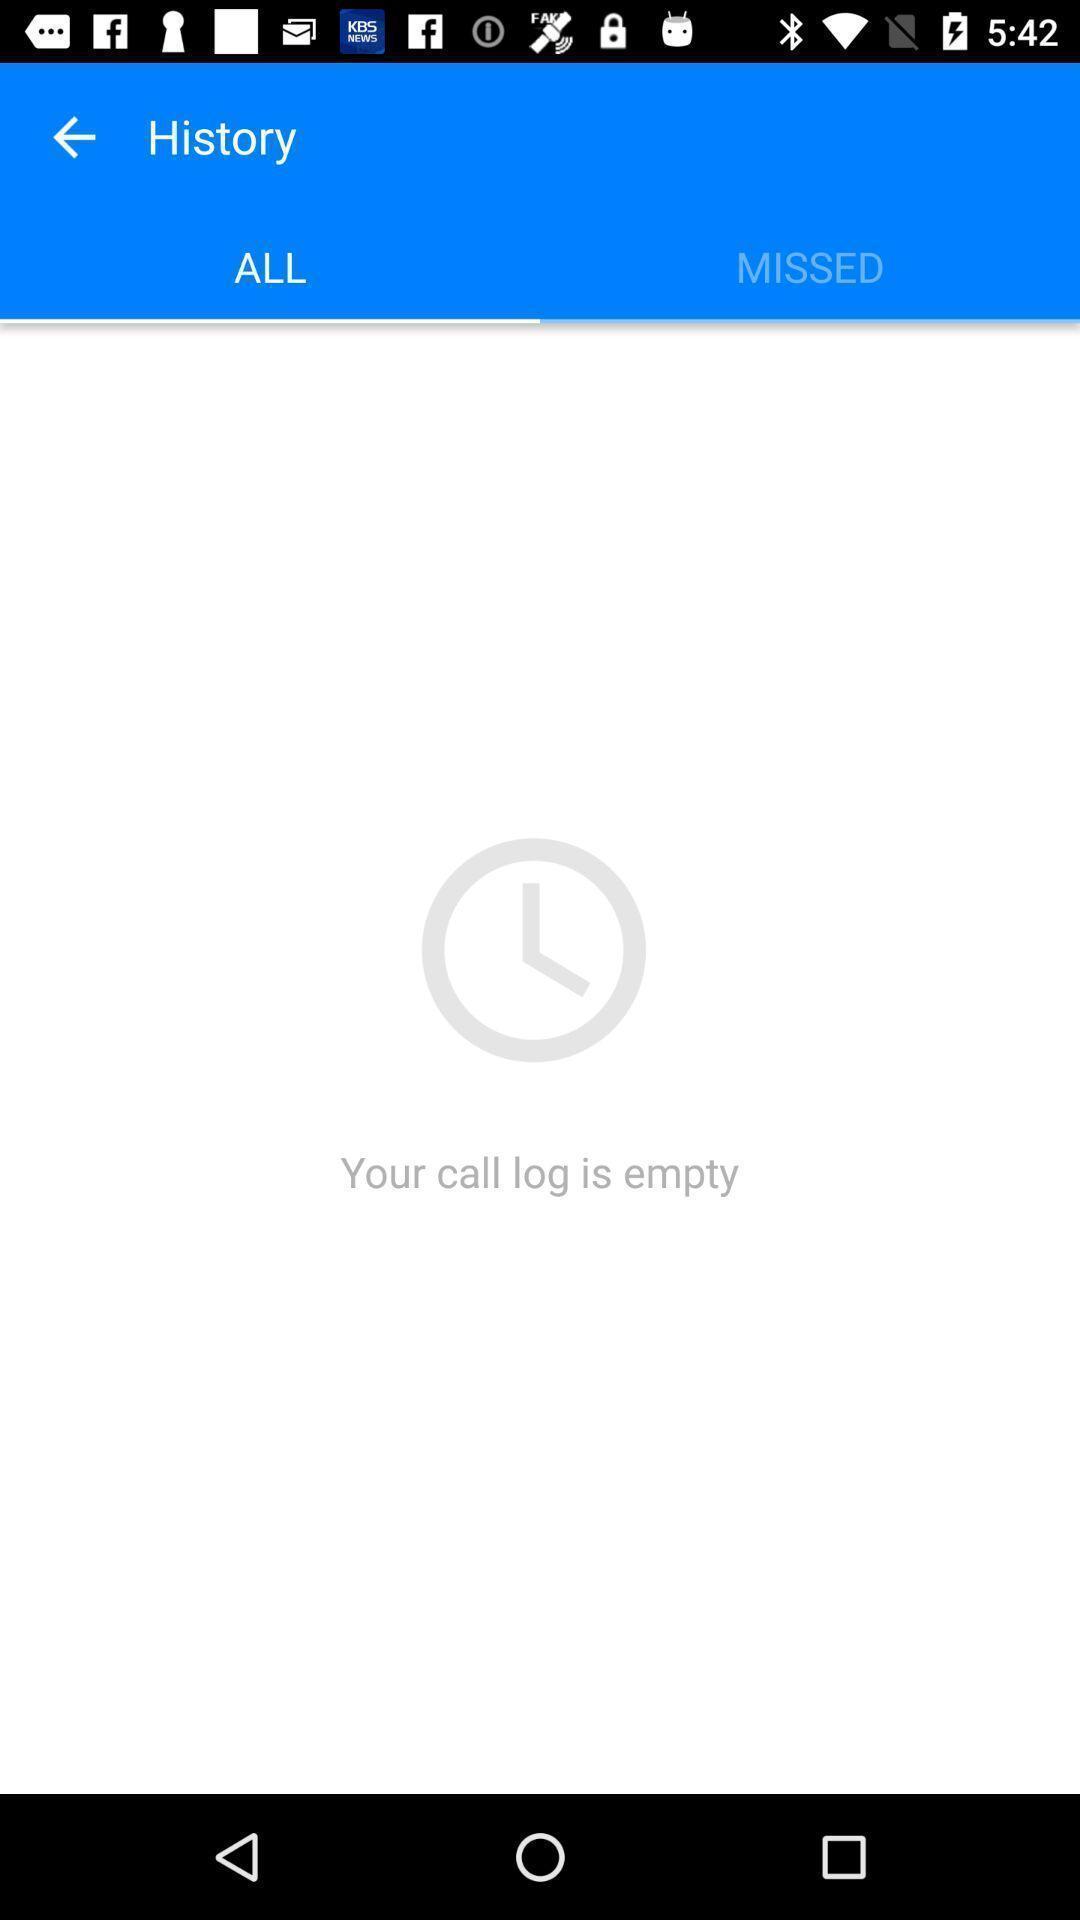Tell me what you see in this picture. Page showing history of your call logs. 